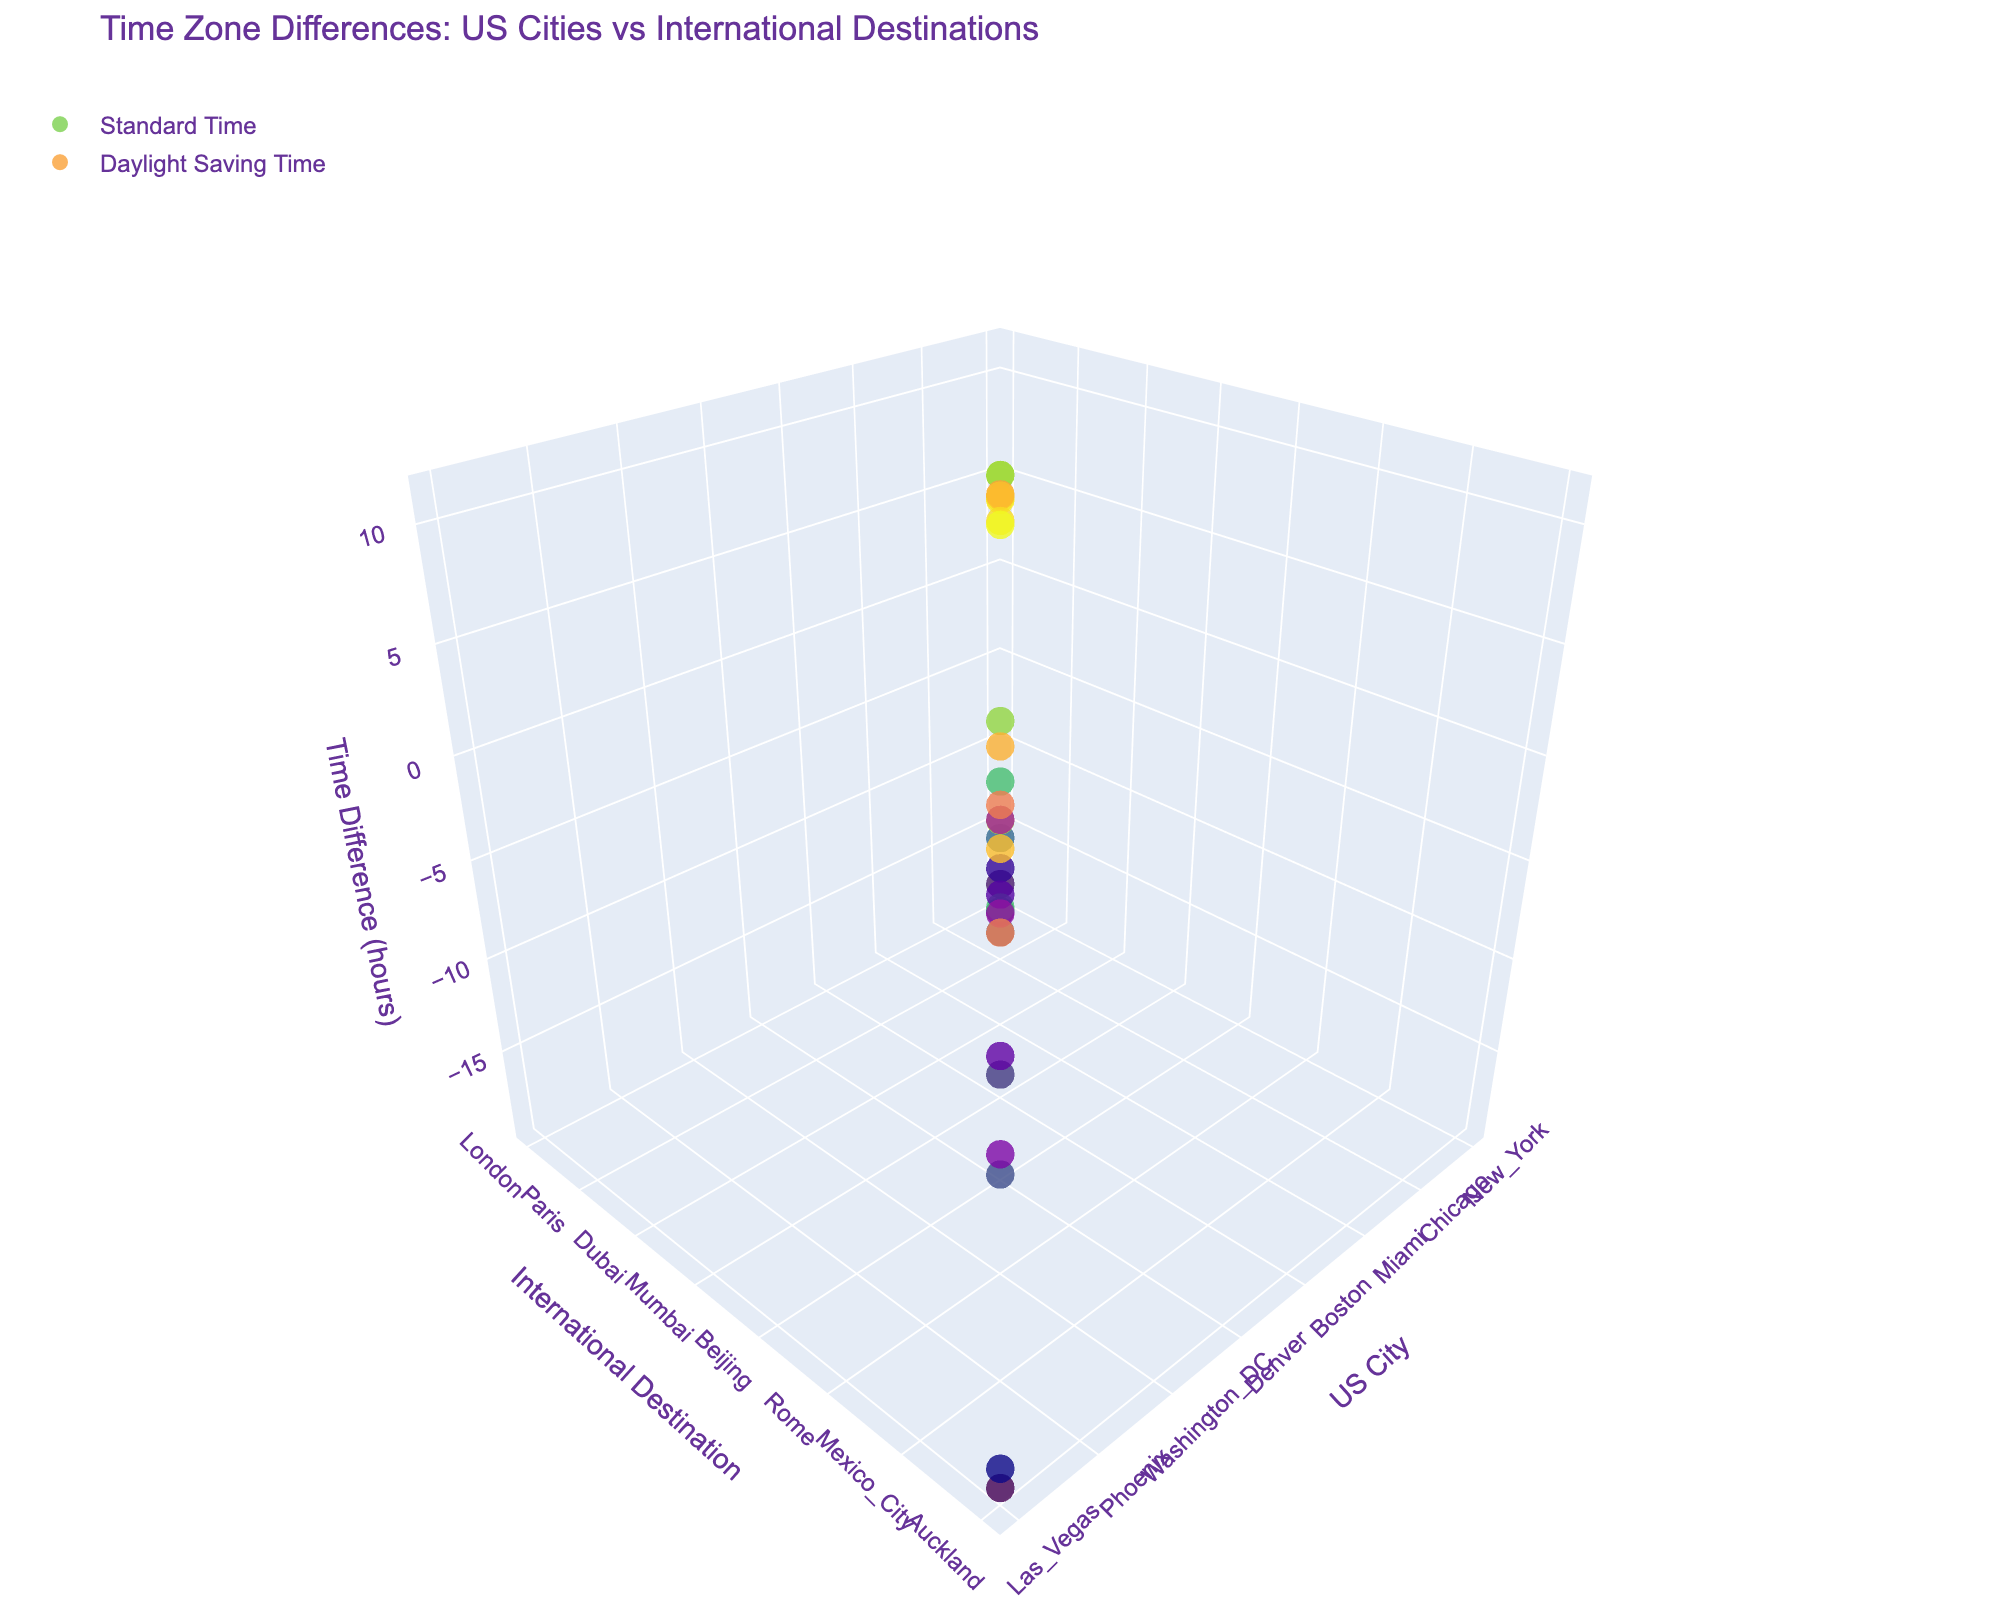What is the title of the figure? The title of the figure is located at the top of the plot and summarizes the main subject of the visualization. It reads, "Time Zone Differences: US Cities vs International Destinations".
Answer: Time Zone Differences: US Cities vs International Destinations How many data points are shown for each US city? Each US city has two data points, one for the Standard Time difference and one for the Daylight Saving Time difference with international destinations.
Answer: 2 Which US city has the largest change in time difference due to Daylight Saving Time? From the hover text, locate the time differences in both Standard Time and Daylight Saving Time for each city. The city with the largest numerical change in time difference is San Francisco, which changes from 9 hours to 8 hours.
Answer: San Francisco What is the time difference in Daylight Saving Time between Los Angeles and Tokyo? Find the Daylight Saving Time difference for Los Angeles and Tokyo by checking the z-axis value connected to the "Los Angeles" marker in the plot. The value is -16.
Answer: -16 Is the time difference between New York and London greater during Standard Time or Daylight Saving Time? By examining the z-axis values for both Standard Time and Daylight Saving Time markers for New York and London: Standard Time is 5 hours, and Daylight Saving Time is 4 hours. Therefore, the difference is greater during Standard Time.
Answer: Standard Time Compare the time difference during Standard Time between Denver and Beijing with that of Houston and Sydney. Which is greater? Locate the Standard Time z-axis values for both pairs. For Denver and Beijing, it is -14 hours, and for Houston and Sydney, it is -15 hours. The time difference between Denver and Beijing is greater.
Answer: Denver and Beijing Which international destination has the smallest time difference from any US city during Daylight Saving Time? Check the z-axis values for the Daylight Saving Time markers and find the smallest absolute value. The smallest time difference during Daylight Saving Time is for Atlanta and Rio de Janeiro, which is 1 hour.
Answer: Rio de Janeiro What is the average time difference during Standard Time for Chicago and Paris, Houston and Sydney? To calculate the average: sum the Standard Time differences (7 for Chicago and Paris, -15 for Houston and Sydney) and divide by 2: (7 + (-15)) / 2 = -4.
Answer: -4 Which international destination has the largest negative time difference during Standard Time for any US city? Identify the z-axis values for the Standard Time markers, looking for the most negative number. The largest negative time difference is for Las Vegas and Auckland, showing -19 hours.
Answer: Auckland 